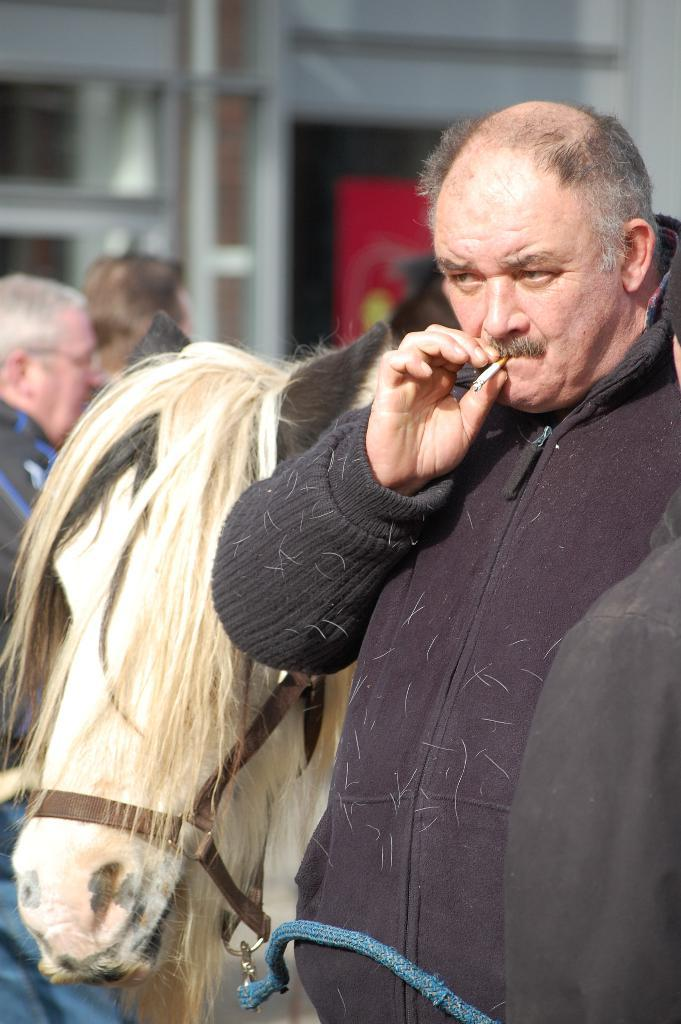What is the man in the image holding? The man is holding a cigar. What is located behind the man in the image? There is a horse behind the man. Can you describe the people in the background of the image? There are people standing in the background of the image, and they are standing on the ground. What type of hospital is visible in the background of the image? There is no hospital present in the image; it features a man holding a cigar, a horse behind him, and people standing in the background. How many zippers can be seen on the man's clothing in the image? There is no mention of zippers on the man's clothing in the image. 